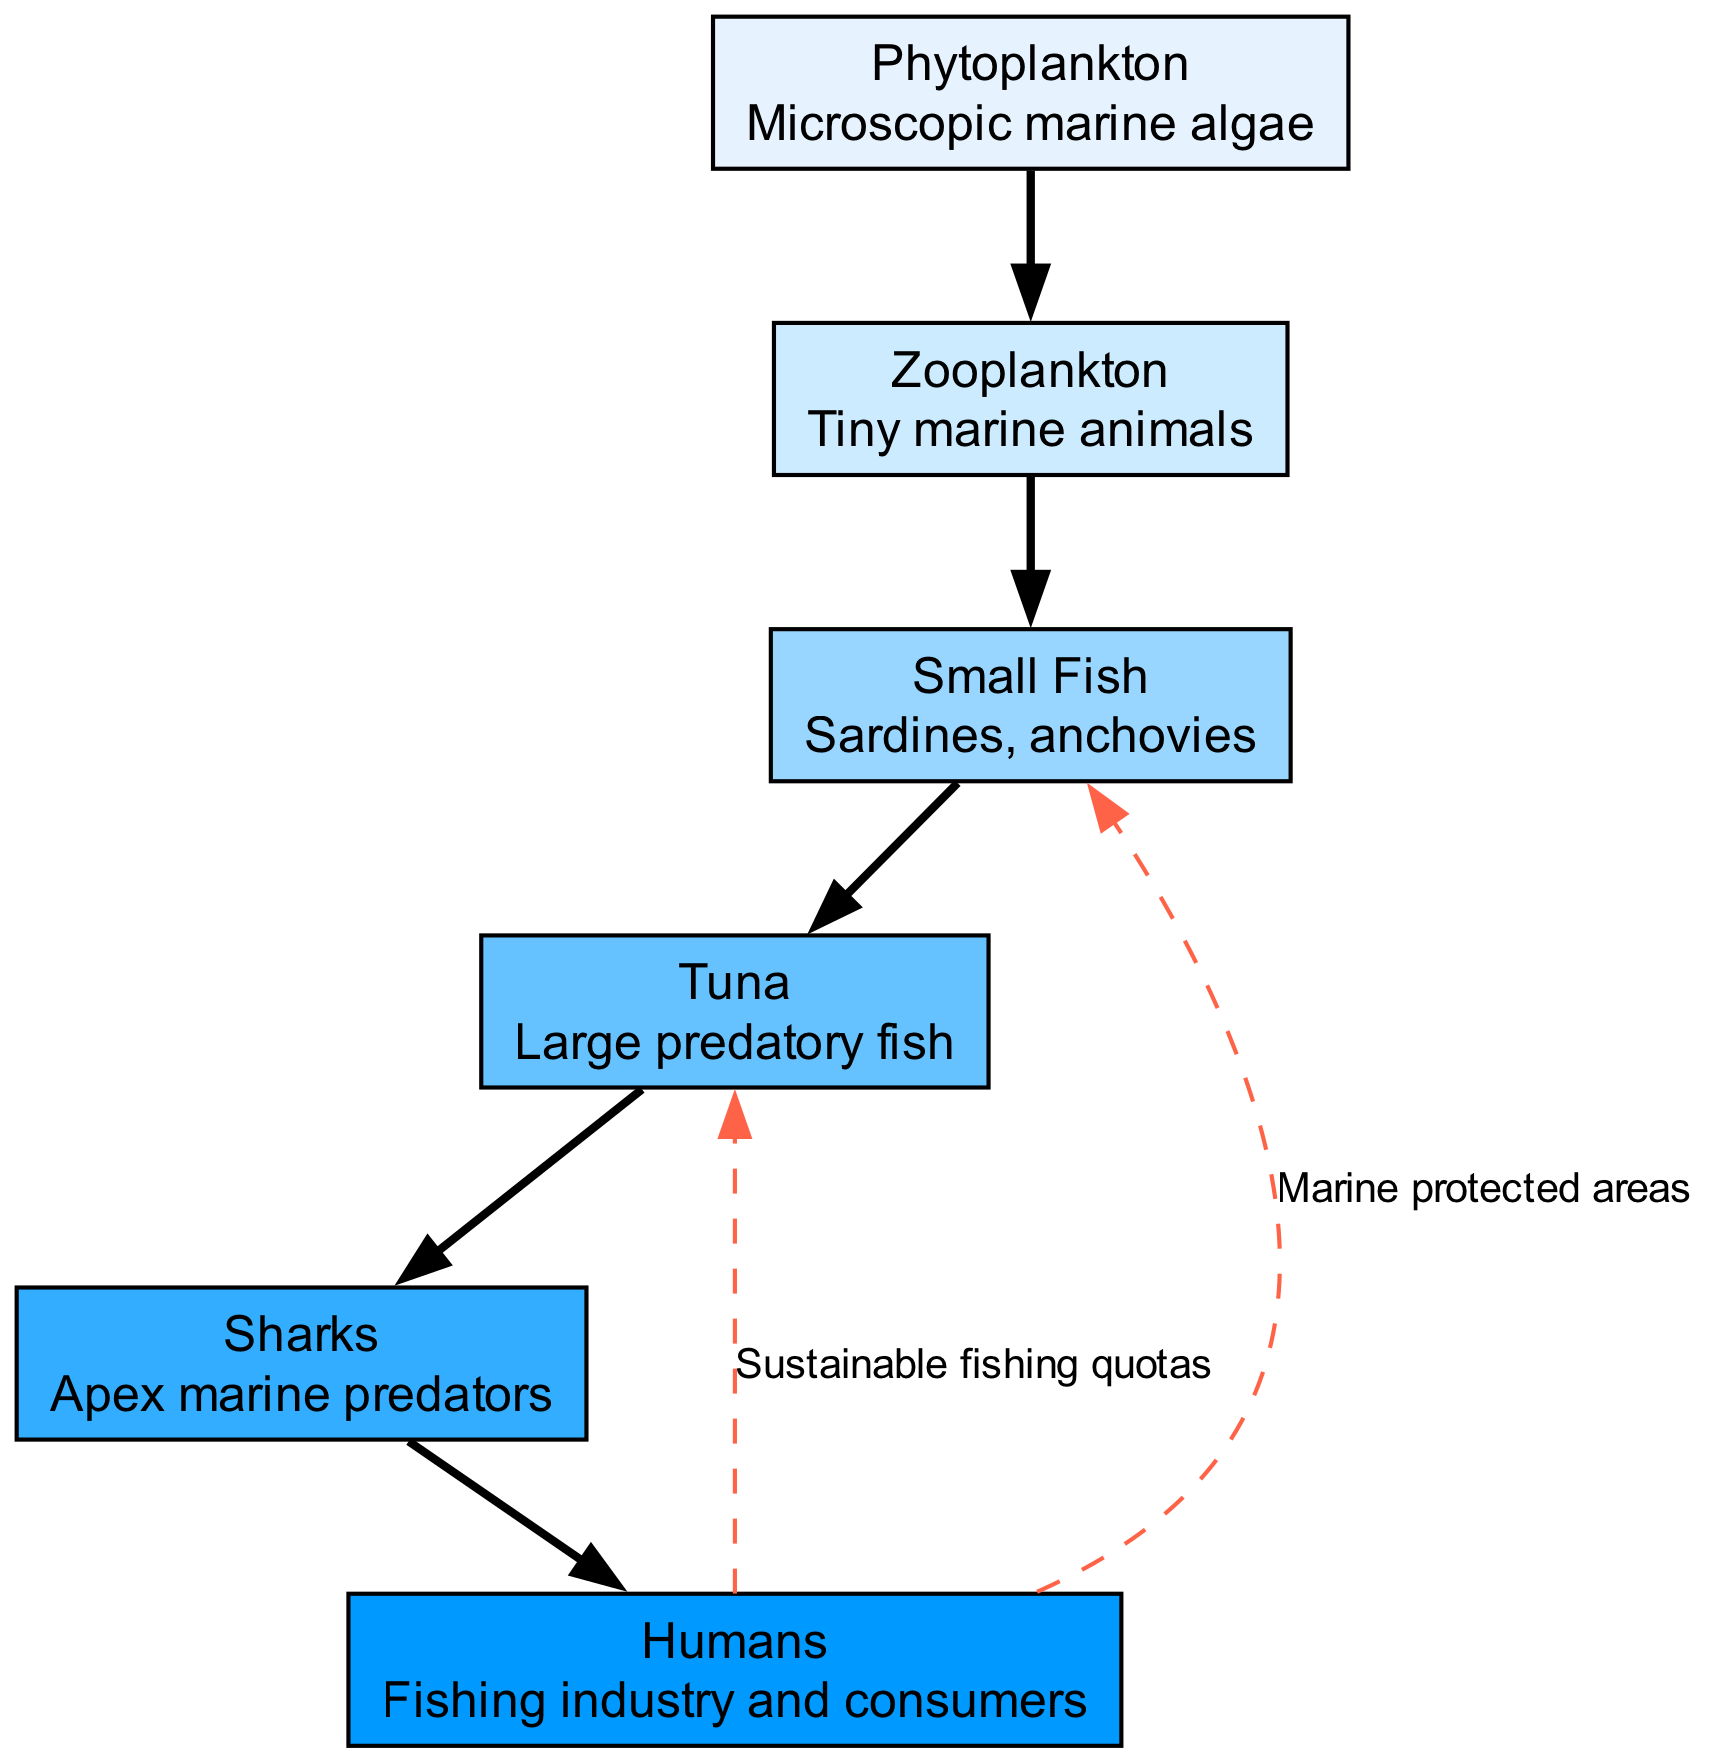What is the lowest level in the food chain? The lowest level in the food chain is represented by the node "Phytoplankton," which is at level 1.
Answer: Phytoplankton Who are the apex predators in this food chain? The apex predators in this food chain are represented by the node "Sharks," which is at the highest level.
Answer: Sharks How many nodes are shown in the diagram? The diagram displays a total of 7 nodes: Phytoplankton, Zooplankton, Small Fish, Tuna, Sharks, and Humans.
Answer: 7 What is the relationship between Humans and Tuna? The diagram indicates the relationship as "Sustainable fishing quotas," meaning there is a direct connection in terms of fishing practices impacting Tuna populations.
Answer: Sustainable fishing quotas Which level does "Small Fish" belong to? "Small Fish" is located at level 3 in the food chain, indicating its position in the hierarchy of the ecosystem.
Answer: Level 3 What impact do Humans have on Small Fish? The impact is described by the edge "Marine protected areas," indicating that Humans establish these areas to help preserve Small Fish populations.
Answer: Marine protected areas What organism is directly above "Zooplankton"? "Small Fish" is the organism directly above "Zooplankton," which means that Zooplankton serve as a food source for Small Fish.
Answer: Small Fish How many edges are there in this food chain? The diagram shows a total of 6 edges connecting the various nodes in the food chain, including both the flow of energy and specific practices by Humans.
Answer: 6 